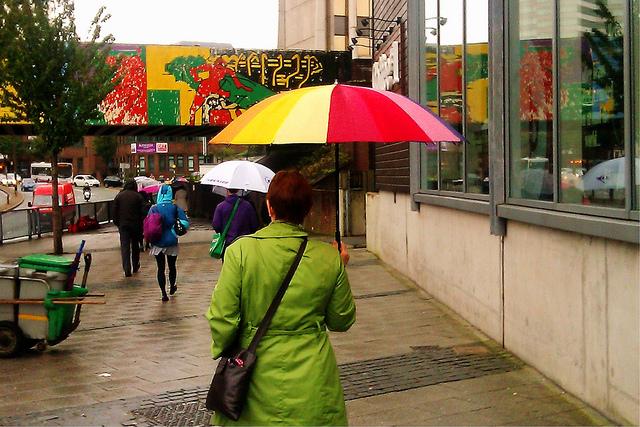Does the woman have a shopping bag?
Answer briefly. No. How many colors are visible on the umbrella being held by the woman in the green coat?
Give a very brief answer. 7. What color is the umbrella being held by the person ahead of the woman in the green coat?
Give a very brief answer. White. 